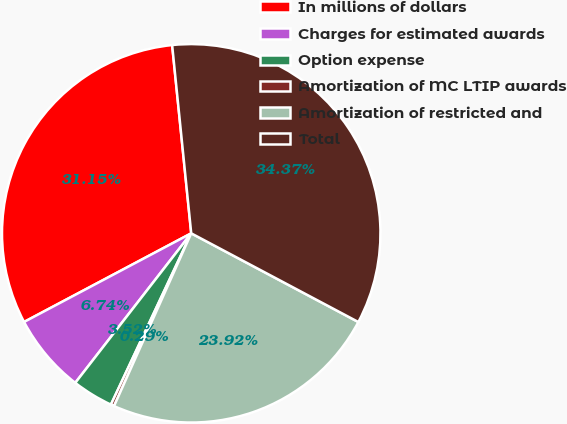Convert chart. <chart><loc_0><loc_0><loc_500><loc_500><pie_chart><fcel>In millions of dollars<fcel>Charges for estimated awards<fcel>Option expense<fcel>Amortization of MC LTIP awards<fcel>Amortization of restricted and<fcel>Total<nl><fcel>31.15%<fcel>6.74%<fcel>3.52%<fcel>0.29%<fcel>23.92%<fcel>34.37%<nl></chart> 